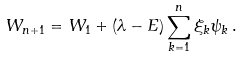<formula> <loc_0><loc_0><loc_500><loc_500>W _ { n + 1 } = W _ { 1 } + ( \lambda - E ) \sum _ { k = 1 } ^ { n } \xi _ { k } \psi _ { k } \, .</formula> 